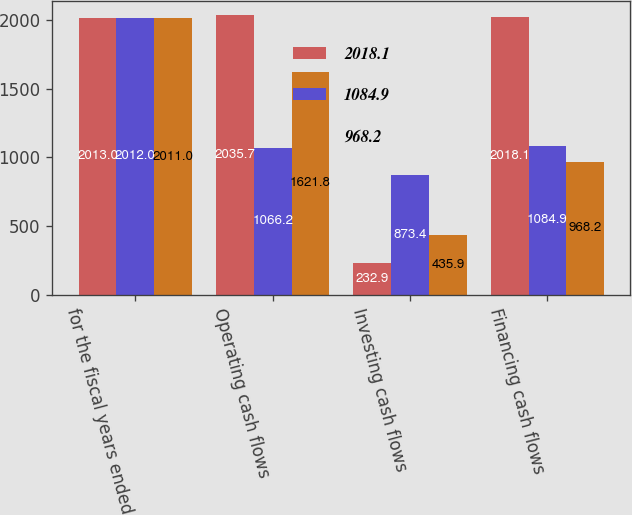Convert chart to OTSL. <chart><loc_0><loc_0><loc_500><loc_500><stacked_bar_chart><ecel><fcel>for the fiscal years ended<fcel>Operating cash flows<fcel>Investing cash flows<fcel>Financing cash flows<nl><fcel>2018.1<fcel>2013<fcel>2035.7<fcel>232.9<fcel>2018.1<nl><fcel>1084.9<fcel>2012<fcel>1066.2<fcel>873.4<fcel>1084.9<nl><fcel>968.2<fcel>2011<fcel>1621.8<fcel>435.9<fcel>968.2<nl></chart> 